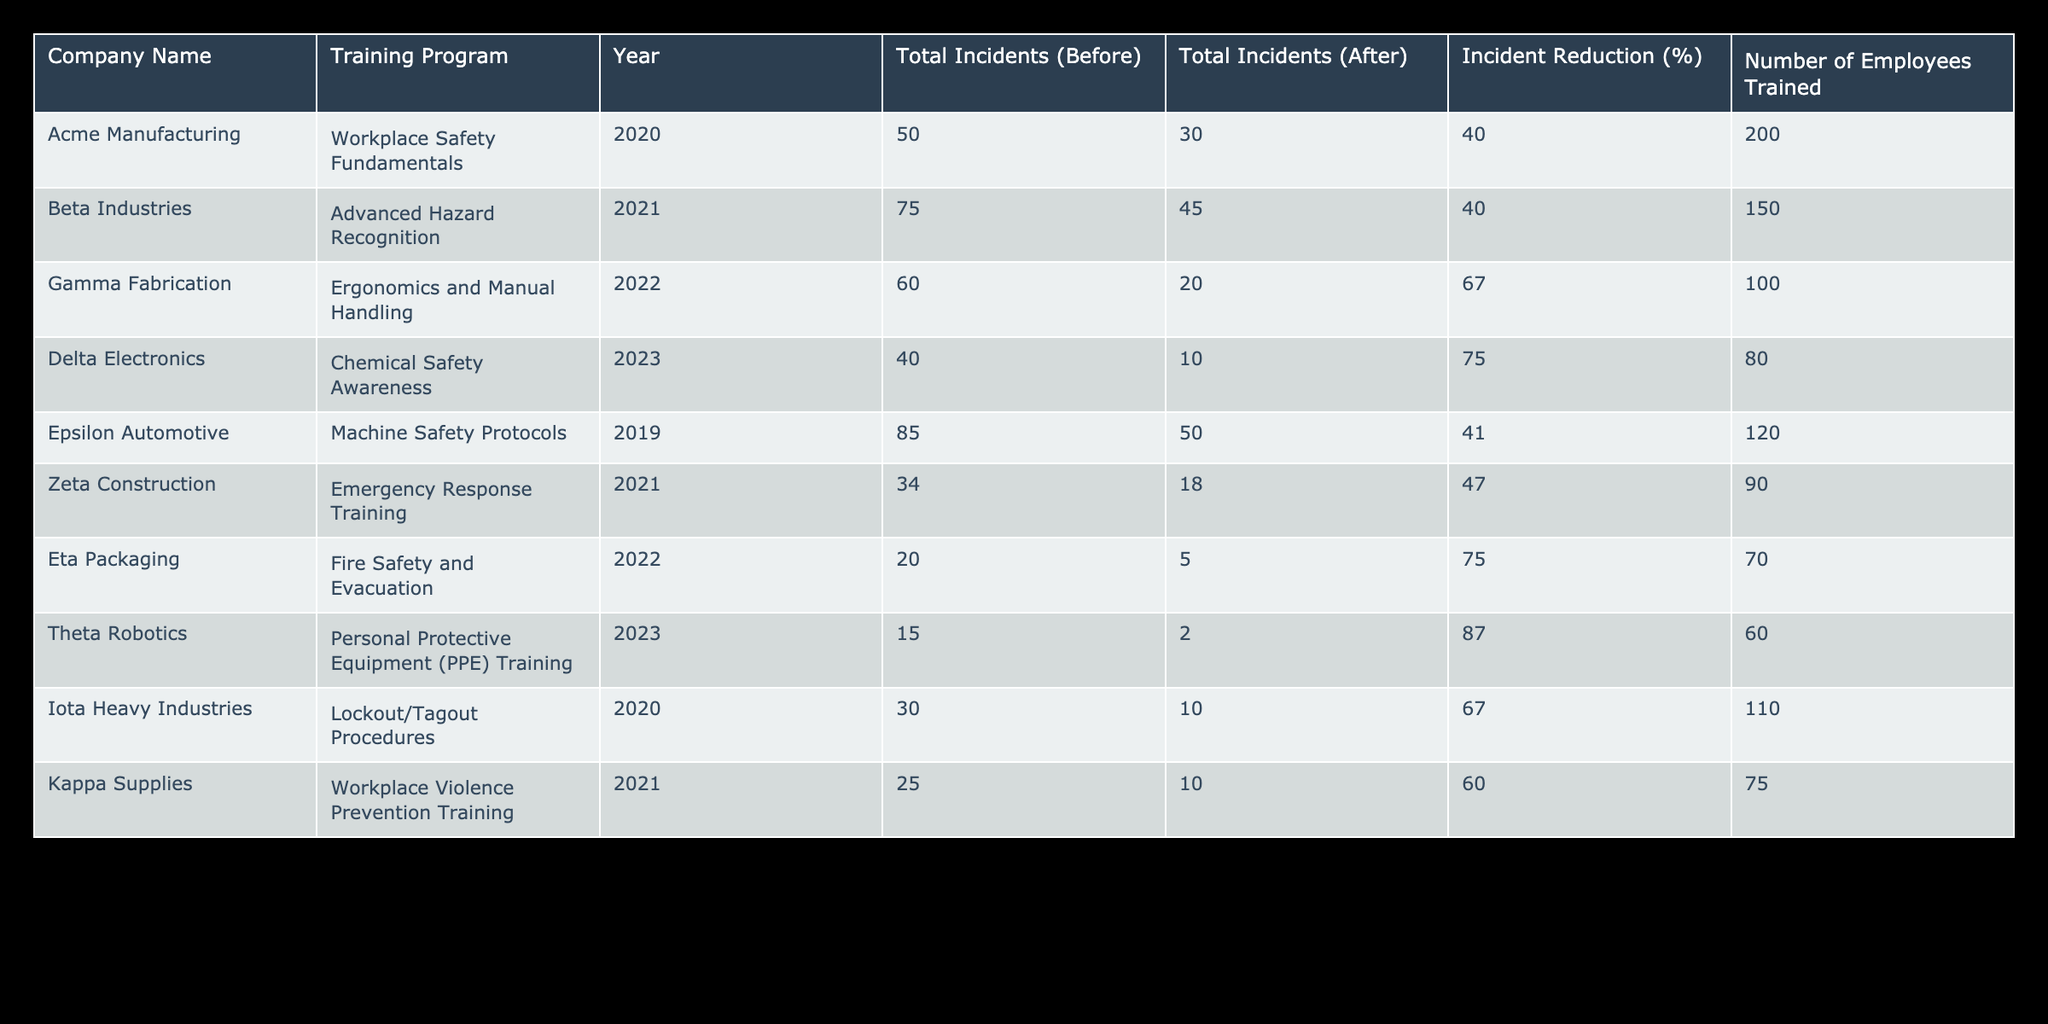What is the incident reduction percentage for Delta Electronics? The table shows that the total incidents before the training at Delta Electronics were 40, and after the training, they were reduced to 10. The incident reduction percentage is calculated as ((40 - 10) / 40) * 100, which equals 75%.
Answer: 75% What training program had the highest incident reduction percentage? Examining the data, Iota Heavy Industries had an incident reduction of 67% and Gamma Fabrication had 67%. However, Theta Robotics achieved the highest incident reduction percentage of 87%.
Answer: 87% How many total incidents occurred in Beta Industries after the training program? Looking at the table for Beta Industries, the total incidents after the Advanced Hazard Recognition training program is listed as 45.
Answer: 45 Which company trained the most employees based on the table? Upon reviewing the column for the number of employees trained, Acme Manufacturing trained 200 employees, which is the highest compared to other companies.
Answer: Acme Manufacturing What is the average incident reduction percentage across all companies? To find the average, we first add the incident reduction percentages: 40 + 40 + 67 + 75 + 41 + 47 + 75 + 87 + 67 + 60, which totals 592. There are 10 companies, so we divide 592 by 10, resulting in an average incident reduction percentage of 59.2%.
Answer: 59.2% Did any company experience a total incident increase post-training? Reviewing the total incidents before and after for each company, all companies show a reduction in incidents. Thus, none experienced an increase in total incidents post-training.
Answer: No How many companies had an incident reduction of 60% or more? Checking the incident reduction percentages, Iota Heavy Industries, Gamma Fabrication, Delta Electronics, Theta Robotics, and Eta Packaging all had reductions of 60% or more. This totals five companies.
Answer: 5 What is the sum of the total incidents before training for all companies? To find the total, we sum up the totals listed for incidents before training: 50 + 75 + 60 + 40 + 85 + 34 + 20 + 15 + 30 + 25 = 490. So the total incidents before training is 490.
Answer: 490 Which company had the lowest total incidents before the training program? The lowest total incidents before the training was for Theta Robotics, which reported just 15 incidents.
Answer: Theta Robotics What percentage of incidents were reduced by Epsilon Automotive? For Epsilon Automotive, the total incidents before training were 85 and after training were 50. The incident reduction percentage is calculated as ((85 - 50) / 85) * 100, resulting in approximately 41.18%.
Answer: 41.18% 